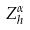Convert formula to latex. <formula><loc_0><loc_0><loc_500><loc_500>Z _ { h } ^ { \alpha }</formula> 